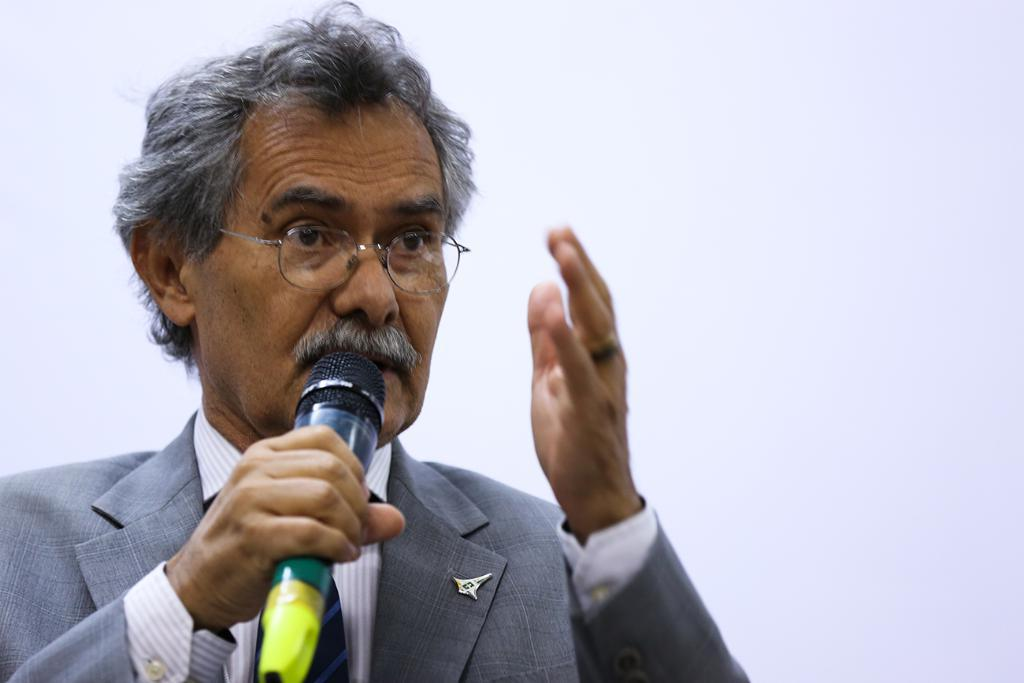Who is the main subject in the image? There is a man in the image. What is the man wearing? The man is wearing spectacles. What is the man holding in his hand? The man is holding a mic in his hand. What is the man doing in the image? The man is talking. What can be seen in the background of the image? There is a wall in the background of the image. How many heart-shaped cables are connected to the man's spectacles in the image? There are no heart-shaped cables connected to the man's spectacles in the image. 